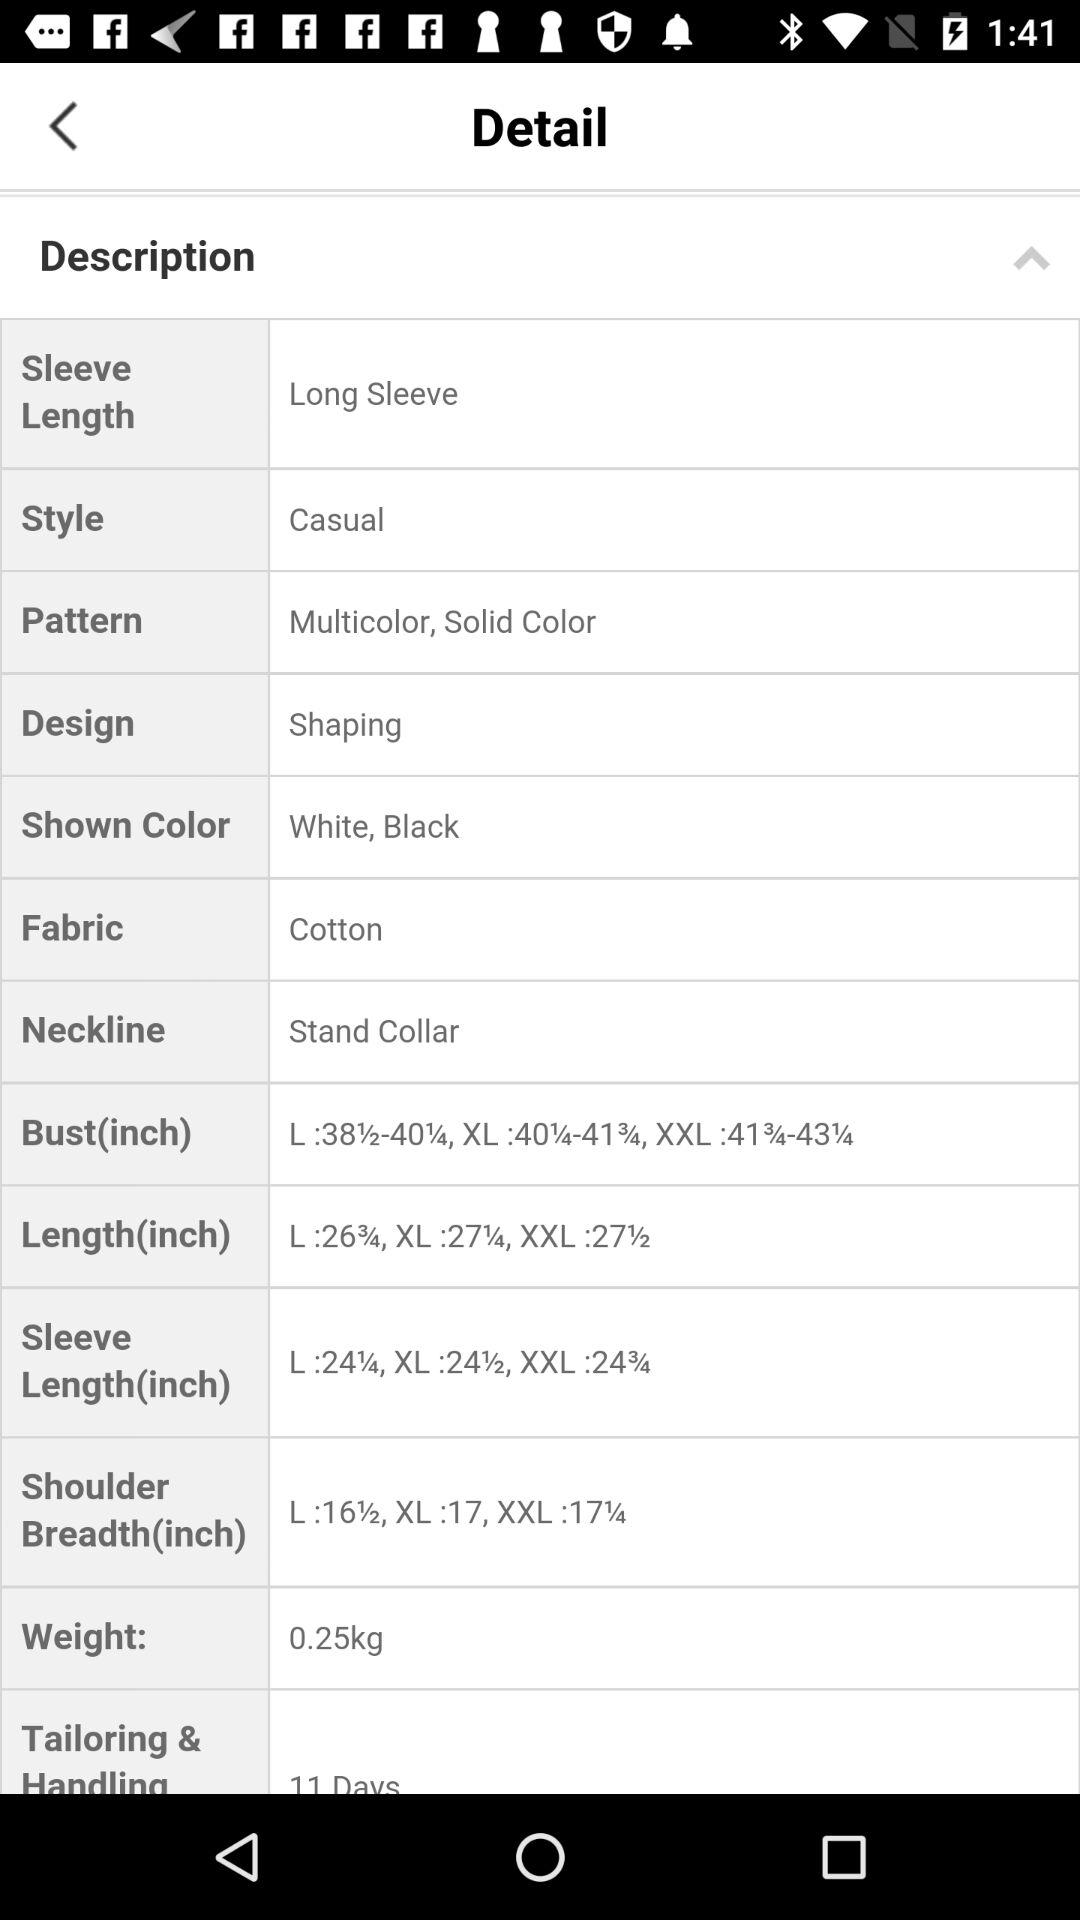What is the selected fabric? The selected fabric is cotton. 